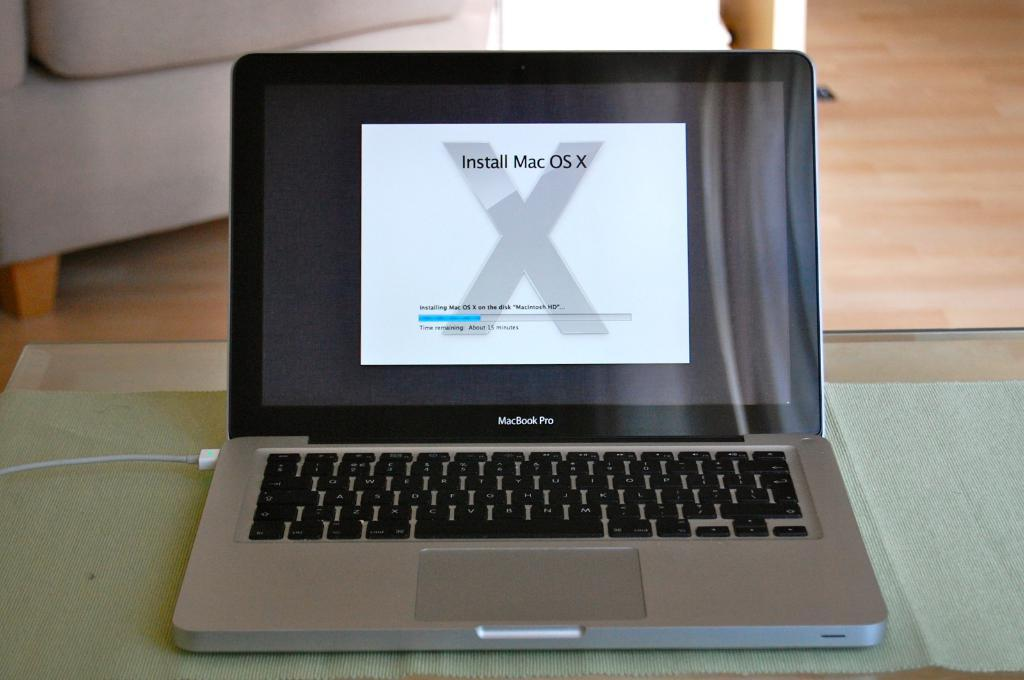<image>
Share a concise interpretation of the image provided. Macbook Pro sitting on a table with a prompt to install Mac OS X. 